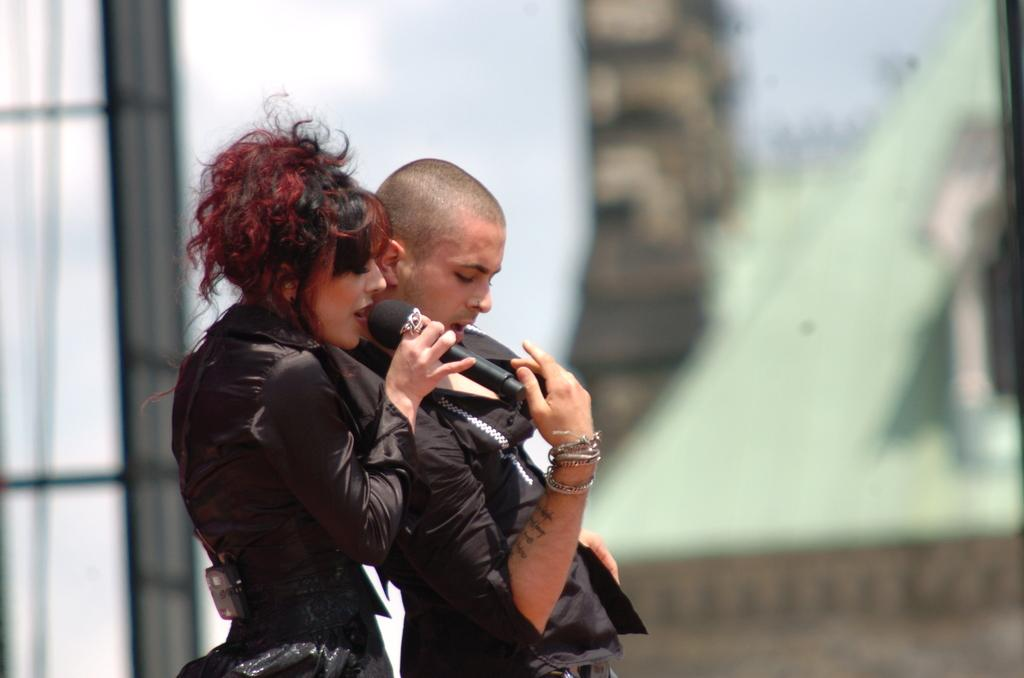What can be observed about the background of the image? The background of the image is blurry. What are the two people in the image doing? The woman and the man are standing and performing. What is the woman holding in her hands? The woman is holding a microphone in her hands. What is the woman doing with the microphone? The woman is singing. What type of root can be seen growing from the woman's feet in the image? There is no root growing from the woman's feet in the image. How does the sky look like in the image? The provided facts do not mention the sky, so it cannot be determined from the image. 